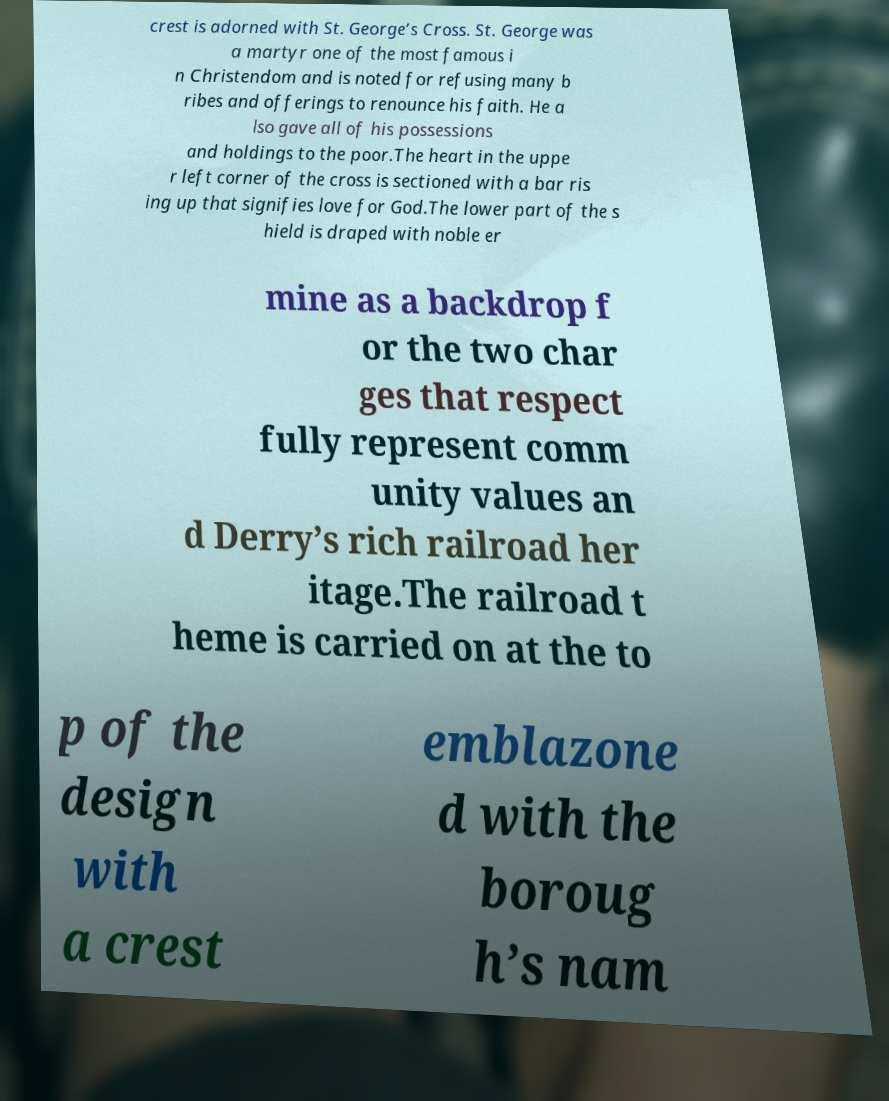Could you extract and type out the text from this image? crest is adorned with St. George’s Cross. St. George was a martyr one of the most famous i n Christendom and is noted for refusing many b ribes and offerings to renounce his faith. He a lso gave all of his possessions and holdings to the poor.The heart in the uppe r left corner of the cross is sectioned with a bar ris ing up that signifies love for God.The lower part of the s hield is draped with noble er mine as a backdrop f or the two char ges that respect fully represent comm unity values an d Derry’s rich railroad her itage.The railroad t heme is carried on at the to p of the design with a crest emblazone d with the boroug h’s nam 